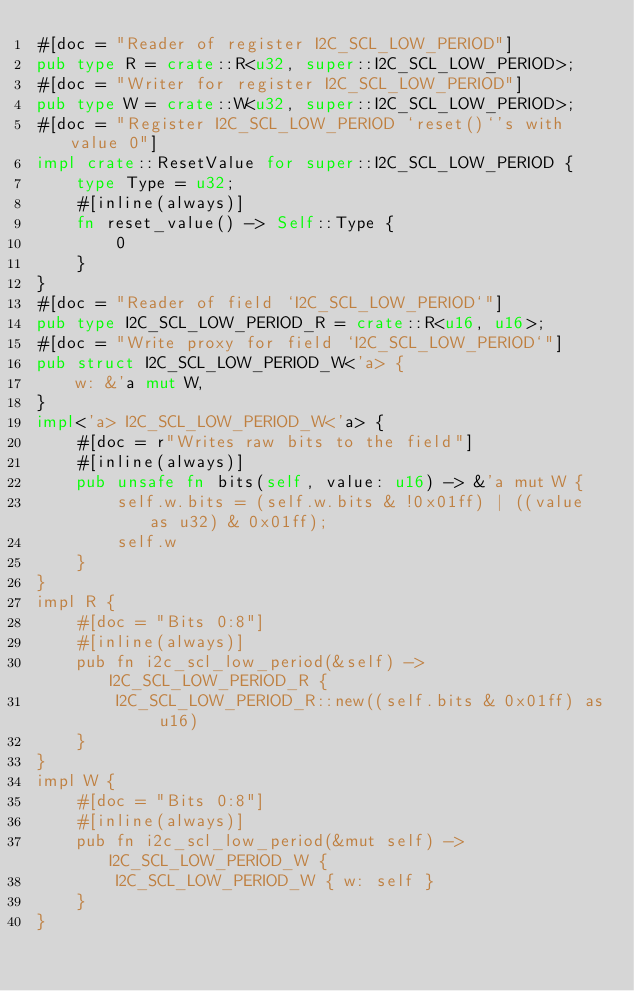<code> <loc_0><loc_0><loc_500><loc_500><_Rust_>#[doc = "Reader of register I2C_SCL_LOW_PERIOD"]
pub type R = crate::R<u32, super::I2C_SCL_LOW_PERIOD>;
#[doc = "Writer for register I2C_SCL_LOW_PERIOD"]
pub type W = crate::W<u32, super::I2C_SCL_LOW_PERIOD>;
#[doc = "Register I2C_SCL_LOW_PERIOD `reset()`'s with value 0"]
impl crate::ResetValue for super::I2C_SCL_LOW_PERIOD {
    type Type = u32;
    #[inline(always)]
    fn reset_value() -> Self::Type {
        0
    }
}
#[doc = "Reader of field `I2C_SCL_LOW_PERIOD`"]
pub type I2C_SCL_LOW_PERIOD_R = crate::R<u16, u16>;
#[doc = "Write proxy for field `I2C_SCL_LOW_PERIOD`"]
pub struct I2C_SCL_LOW_PERIOD_W<'a> {
    w: &'a mut W,
}
impl<'a> I2C_SCL_LOW_PERIOD_W<'a> {
    #[doc = r"Writes raw bits to the field"]
    #[inline(always)]
    pub unsafe fn bits(self, value: u16) -> &'a mut W {
        self.w.bits = (self.w.bits & !0x01ff) | ((value as u32) & 0x01ff);
        self.w
    }
}
impl R {
    #[doc = "Bits 0:8"]
    #[inline(always)]
    pub fn i2c_scl_low_period(&self) -> I2C_SCL_LOW_PERIOD_R {
        I2C_SCL_LOW_PERIOD_R::new((self.bits & 0x01ff) as u16)
    }
}
impl W {
    #[doc = "Bits 0:8"]
    #[inline(always)]
    pub fn i2c_scl_low_period(&mut self) -> I2C_SCL_LOW_PERIOD_W {
        I2C_SCL_LOW_PERIOD_W { w: self }
    }
}
</code> 